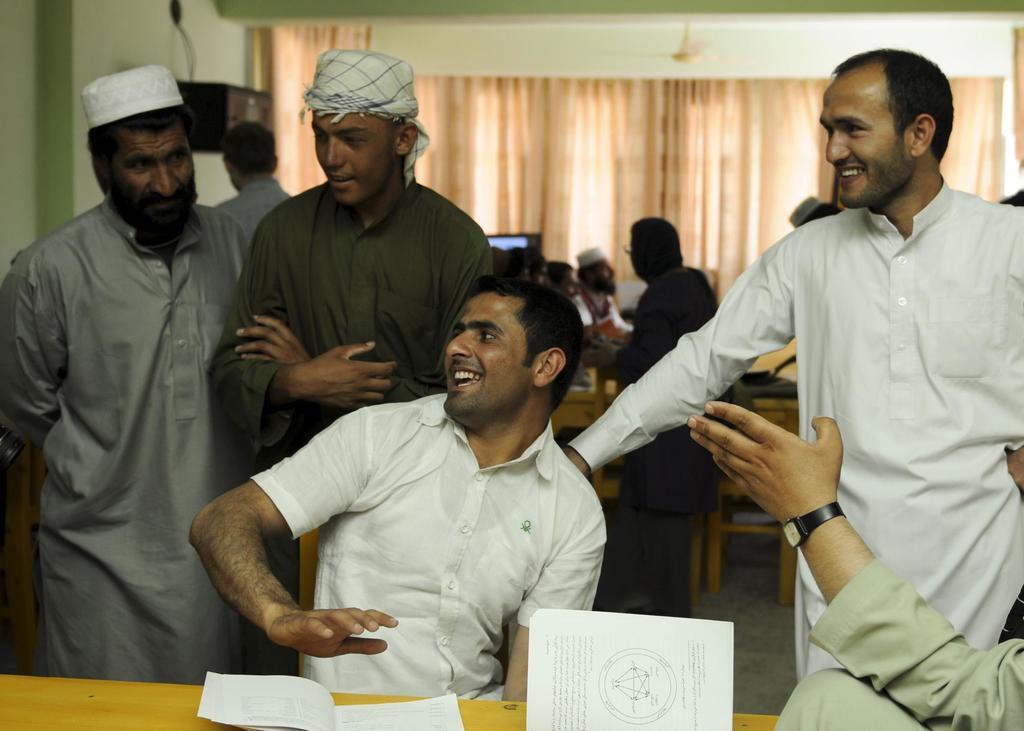Describe this image in one or two sentences. In this image we can see few people in a room, some of them are standing and some of them are sitting on chairs and in the background there is a curtain, a fan to the ceiling and a box to the wall. 